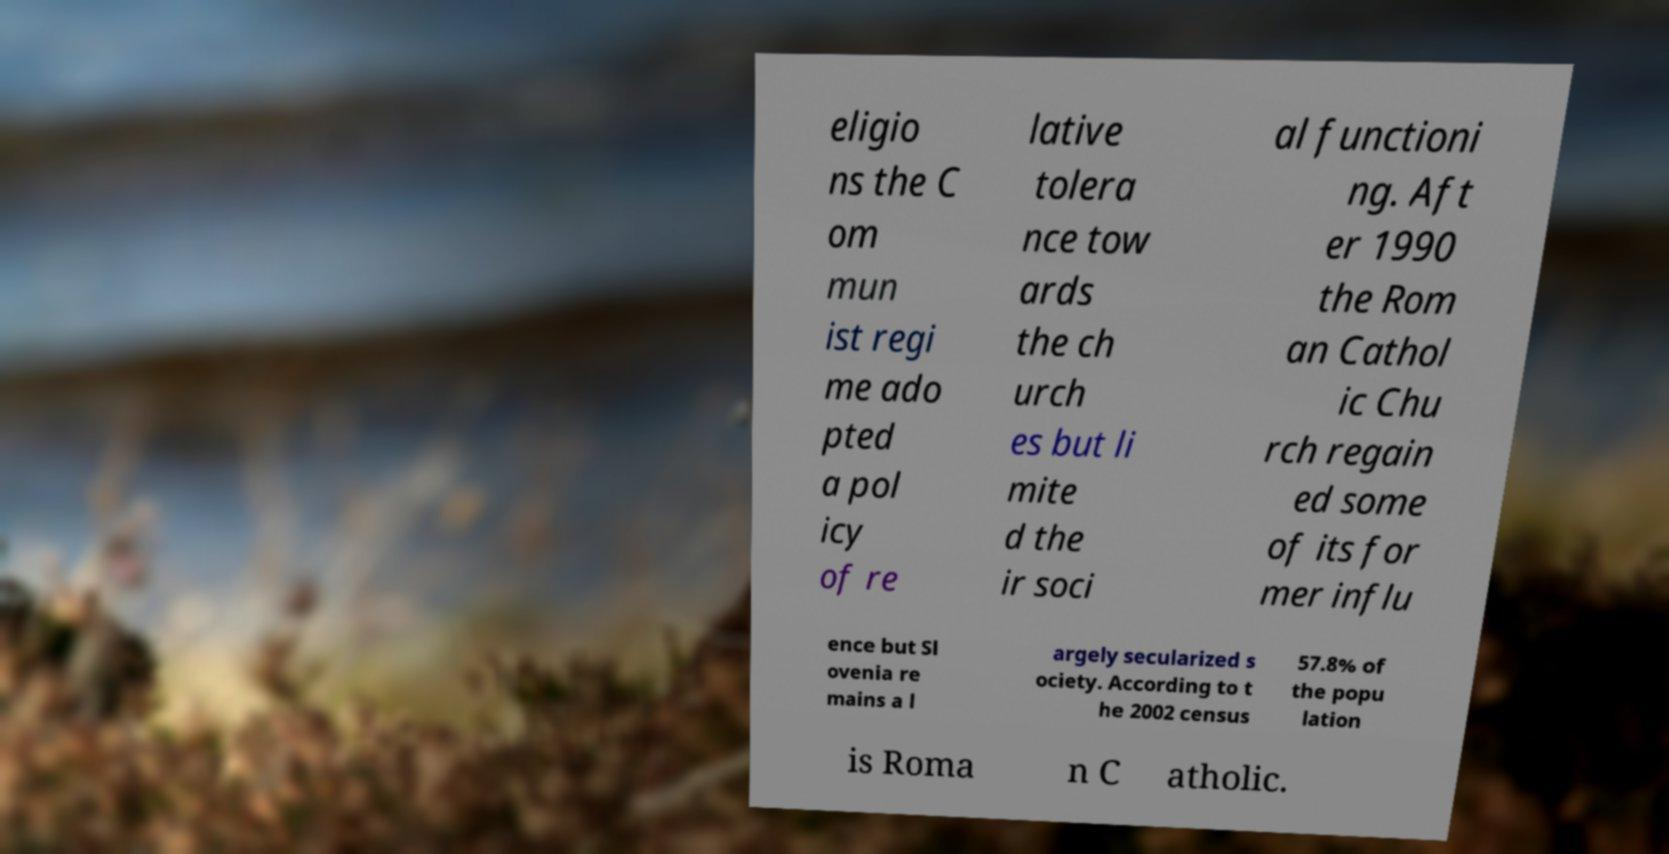Could you assist in decoding the text presented in this image and type it out clearly? eligio ns the C om mun ist regi me ado pted a pol icy of re lative tolera nce tow ards the ch urch es but li mite d the ir soci al functioni ng. Aft er 1990 the Rom an Cathol ic Chu rch regain ed some of its for mer influ ence but Sl ovenia re mains a l argely secularized s ociety. According to t he 2002 census 57.8% of the popu lation is Roma n C atholic. 